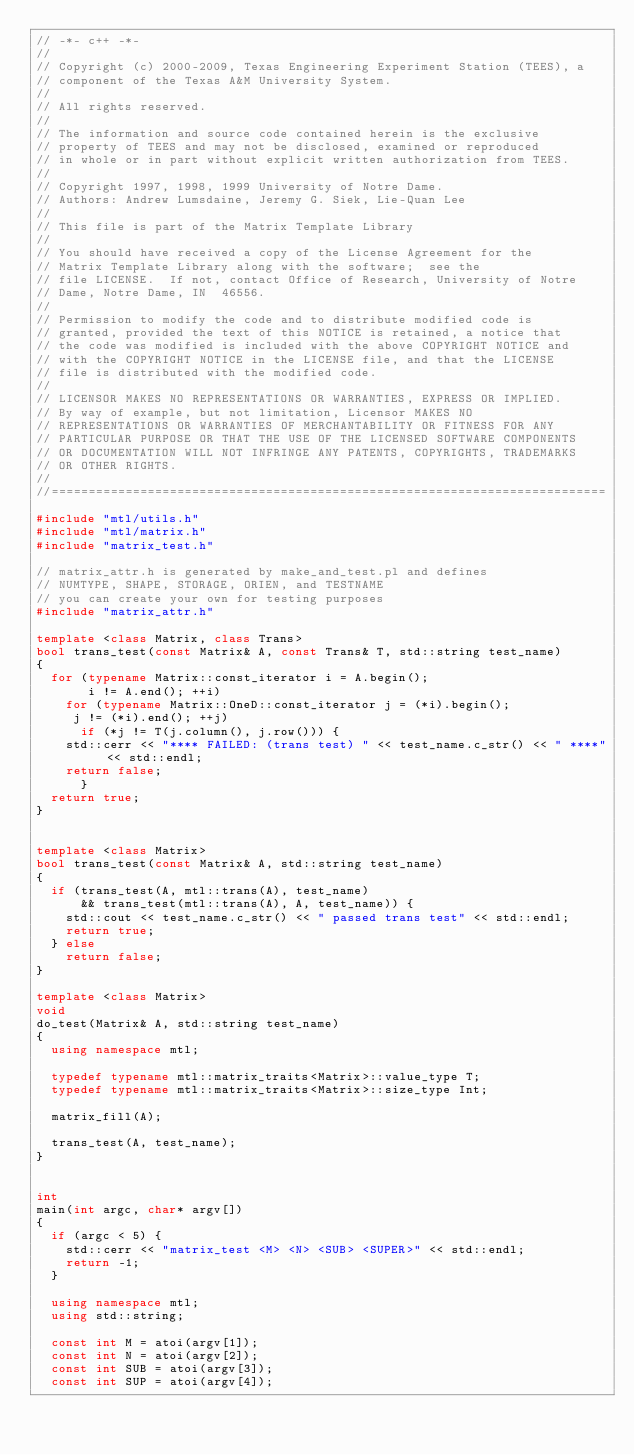Convert code to text. <code><loc_0><loc_0><loc_500><loc_500><_C++_>// -*- c++ -*-
//
// Copyright (c) 2000-2009, Texas Engineering Experiment Station (TEES), a
// component of the Texas A&M University System.
//
// All rights reserved.
//
// The information and source code contained herein is the exclusive
// property of TEES and may not be disclosed, examined or reproduced
// in whole or in part without explicit written authorization from TEES.
//
// Copyright 1997, 1998, 1999 University of Notre Dame.
// Authors: Andrew Lumsdaine, Jeremy G. Siek, Lie-Quan Lee
//
// This file is part of the Matrix Template Library
//
// You should have received a copy of the License Agreement for the
// Matrix Template Library along with the software;  see the
// file LICENSE.  If not, contact Office of Research, University of Notre
// Dame, Notre Dame, IN  46556.
//
// Permission to modify the code and to distribute modified code is
// granted, provided the text of this NOTICE is retained, a notice that
// the code was modified is included with the above COPYRIGHT NOTICE and
// with the COPYRIGHT NOTICE in the LICENSE file, and that the LICENSE
// file is distributed with the modified code.
//
// LICENSOR MAKES NO REPRESENTATIONS OR WARRANTIES, EXPRESS OR IMPLIED.
// By way of example, but not limitation, Licensor MAKES NO
// REPRESENTATIONS OR WARRANTIES OF MERCHANTABILITY OR FITNESS FOR ANY
// PARTICULAR PURPOSE OR THAT THE USE OF THE LICENSED SOFTWARE COMPONENTS
// OR DOCUMENTATION WILL NOT INFRINGE ANY PATENTS, COPYRIGHTS, TRADEMARKS
// OR OTHER RIGHTS.
//
//===========================================================================

#include "mtl/utils.h"
#include "mtl/matrix.h"
#include "matrix_test.h"

// matrix_attr.h is generated by make_and_test.pl and defines
// NUMTYPE, SHAPE, STORAGE, ORIEN, and TESTNAME
// you can create your own for testing purposes
#include "matrix_attr.h"

template <class Matrix, class Trans>
bool trans_test(const Matrix& A, const Trans& T, std::string test_name)
{
  for (typename Matrix::const_iterator i = A.begin();
       i != A.end(); ++i)
    for (typename Matrix::OneD::const_iterator j = (*i).begin();
	 j != (*i).end(); ++j)
      if (*j != T(j.column(), j.row())) {
	std::cerr << "**** FAILED: (trans test) " << test_name.c_str() << " ****" << std::endl;
	return false;
      }
  return true;
}


template <class Matrix>
bool trans_test(const Matrix& A, std::string test_name)
{
  if (trans_test(A, mtl::trans(A), test_name) 
      && trans_test(mtl::trans(A), A, test_name)) {
    std::cout << test_name.c_str() << " passed trans test" << std::endl;
    return true;
  } else
    return false;
}

template <class Matrix>
void
do_test(Matrix& A, std::string test_name)
{
  using namespace mtl;

  typedef typename mtl::matrix_traits<Matrix>::value_type T;
  typedef typename mtl::matrix_traits<Matrix>::size_type Int;

  matrix_fill(A);

  trans_test(A, test_name);
}


int
main(int argc, char* argv[])
{
  if (argc < 5) {
    std::cerr << "matrix_test <M> <N> <SUB> <SUPER>" << std::endl;
    return -1;
  }

  using namespace mtl;
  using std::string;

  const int M = atoi(argv[1]);
  const int N = atoi(argv[2]);
  const int SUB = atoi(argv[3]);
  const int SUP = atoi(argv[4]);
</code> 